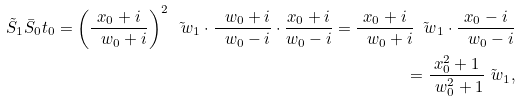<formula> <loc_0><loc_0><loc_500><loc_500>\tilde { S } _ { 1 } \bar { S } _ { 0 } t _ { 0 } = \left ( \frac { x _ { 0 } + i } { \ w _ { 0 } + i } \right ) ^ { 2 } \tilde { \ w } _ { 1 } \cdot \frac { \ w _ { 0 } + i } { \ w _ { 0 } - i } \cdot \frac { x _ { 0 } + i } { w _ { 0 } - i } = \frac { x _ { 0 } + i } { \ w _ { 0 } + i } \tilde { \ w } _ { 1 } \cdot \frac { x _ { 0 } - i } { \ w _ { 0 } - i } \\ = \frac { x _ { 0 } ^ { 2 } + 1 } { \ w _ { 0 } ^ { 2 } + 1 } \tilde { \ w } _ { 1 } ,</formula> 